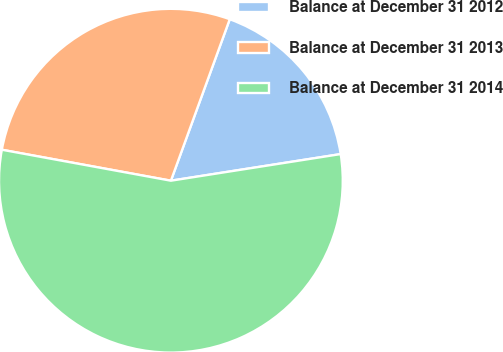Convert chart. <chart><loc_0><loc_0><loc_500><loc_500><pie_chart><fcel>Balance at December 31 2012<fcel>Balance at December 31 2013<fcel>Balance at December 31 2014<nl><fcel>16.96%<fcel>27.68%<fcel>55.36%<nl></chart> 